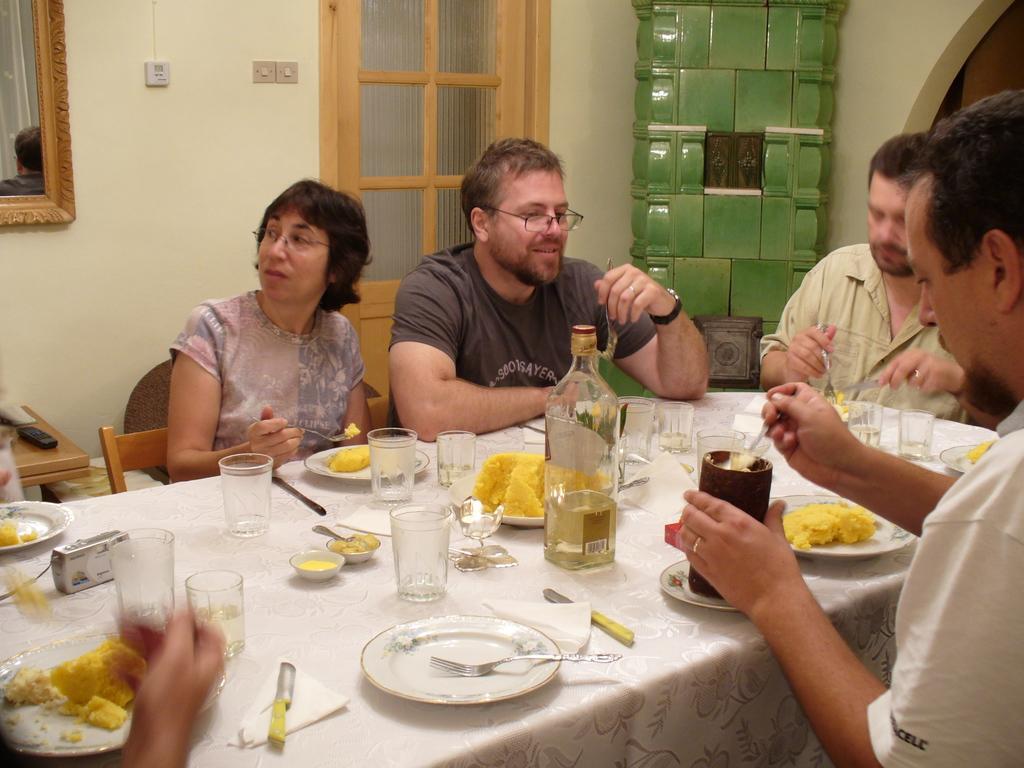In one or two sentences, can you explain what this image depicts? This picture shows few glasses, bottle and food in the plates and we see knives, Forks and a camera on the table and we see a man holding a bottle and a spoon in another hand and we see few people seated on the chairs and we see a door and a photo frame on the wall. 